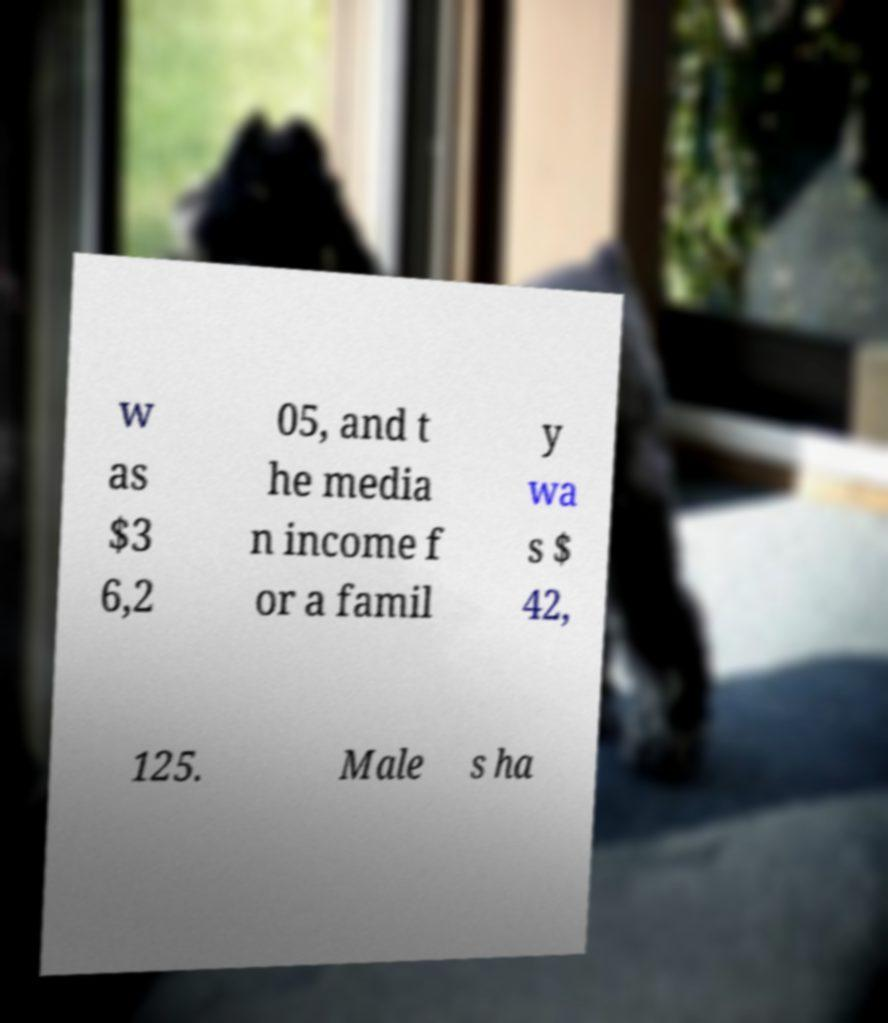Could you extract and type out the text from this image? w as $3 6,2 05, and t he media n income f or a famil y wa s $ 42, 125. Male s ha 